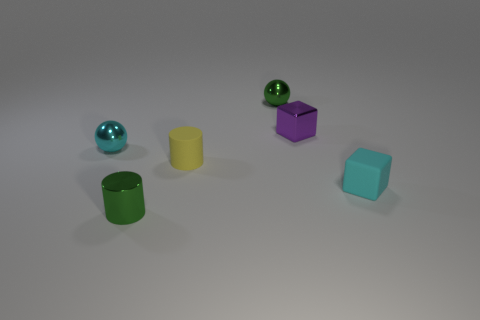Are there any small green balls on the right side of the tiny rubber object that is on the right side of the shiny block?
Offer a very short reply. No. What number of other things are there of the same material as the tiny purple cube
Your answer should be compact. 3. There is a matte thing that is in front of the small yellow cylinder; is it the same shape as the green thing to the left of the yellow rubber thing?
Provide a short and direct response. No. Is the small yellow object made of the same material as the cyan ball?
Your answer should be very brief. No. How big is the shiny ball on the right side of the small cyan thing that is on the left side of the tiny cyan block to the right of the tiny metal cylinder?
Your response must be concise. Small. What number of other objects are the same color as the metallic block?
Offer a terse response. 0. There is a yellow thing that is the same size as the purple metallic block; what shape is it?
Ensure brevity in your answer.  Cylinder. How many tiny things are either cyan spheres or matte blocks?
Ensure brevity in your answer.  2. Is there a tiny cyan matte object in front of the small matte thing right of the object that is behind the tiny purple block?
Make the answer very short. No. Are there any green metallic objects that have the same size as the yellow matte object?
Provide a succinct answer. Yes. 